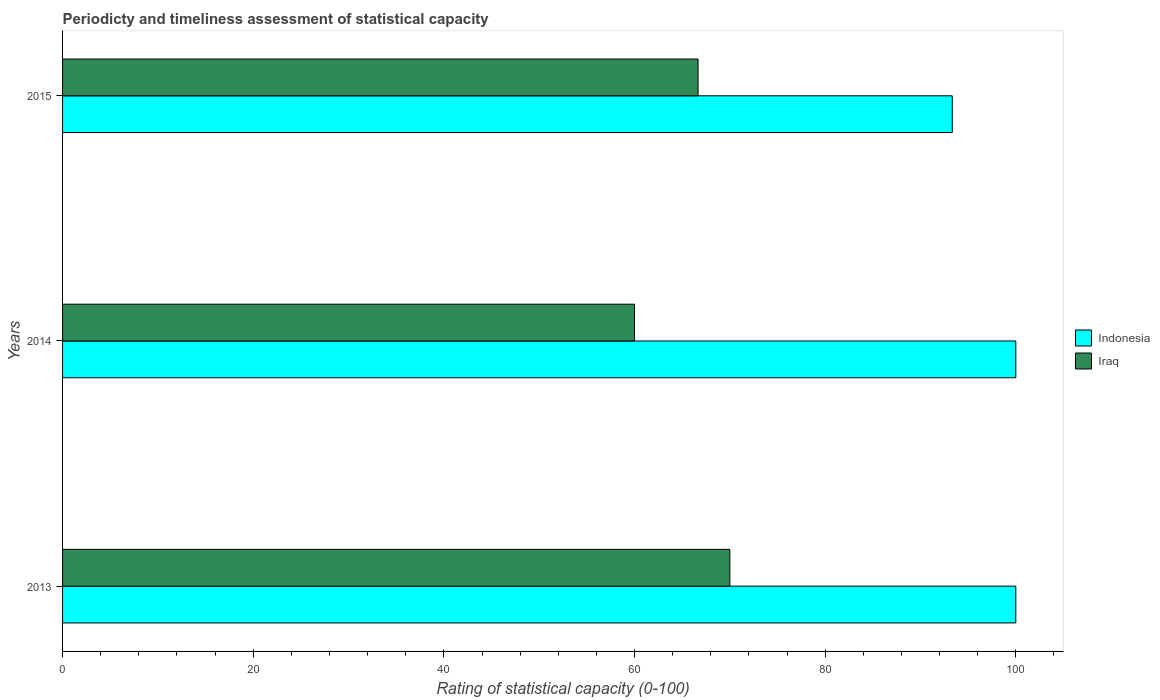How many different coloured bars are there?
Your answer should be compact. 2. How many groups of bars are there?
Your answer should be very brief. 3. What is the label of the 1st group of bars from the top?
Make the answer very short. 2015. In how many cases, is the number of bars for a given year not equal to the number of legend labels?
Provide a short and direct response. 0. What is the rating of statistical capacity in Iraq in 2015?
Keep it short and to the point. 66.67. Across all years, what is the minimum rating of statistical capacity in Indonesia?
Ensure brevity in your answer.  93.33. In which year was the rating of statistical capacity in Indonesia maximum?
Offer a terse response. 2013. In which year was the rating of statistical capacity in Indonesia minimum?
Provide a succinct answer. 2015. What is the total rating of statistical capacity in Indonesia in the graph?
Keep it short and to the point. 293.33. What is the difference between the rating of statistical capacity in Indonesia in 2013 and that in 2015?
Offer a terse response. 6.67. What is the average rating of statistical capacity in Iraq per year?
Your answer should be compact. 65.56. In how many years, is the rating of statistical capacity in Iraq greater than 32 ?
Your answer should be very brief. 3. What is the ratio of the rating of statistical capacity in Iraq in 2013 to that in 2015?
Provide a succinct answer. 1.05. Is the difference between the rating of statistical capacity in Indonesia in 2013 and 2014 greater than the difference between the rating of statistical capacity in Iraq in 2013 and 2014?
Ensure brevity in your answer.  No. What is the difference between the highest and the second highest rating of statistical capacity in Iraq?
Offer a very short reply. 3.33. What is the difference between the highest and the lowest rating of statistical capacity in Indonesia?
Ensure brevity in your answer.  6.67. What does the 2nd bar from the top in 2014 represents?
Provide a succinct answer. Indonesia. What does the 1st bar from the bottom in 2014 represents?
Provide a short and direct response. Indonesia. How many bars are there?
Make the answer very short. 6. What is the difference between two consecutive major ticks on the X-axis?
Give a very brief answer. 20. Are the values on the major ticks of X-axis written in scientific E-notation?
Provide a succinct answer. No. Does the graph contain any zero values?
Your answer should be compact. No. How are the legend labels stacked?
Your answer should be compact. Vertical. What is the title of the graph?
Offer a terse response. Periodicty and timeliness assessment of statistical capacity. Does "Kenya" appear as one of the legend labels in the graph?
Provide a succinct answer. No. What is the label or title of the X-axis?
Provide a succinct answer. Rating of statistical capacity (0-100). What is the Rating of statistical capacity (0-100) of Indonesia in 2013?
Your response must be concise. 100. What is the Rating of statistical capacity (0-100) of Iraq in 2013?
Keep it short and to the point. 70. What is the Rating of statistical capacity (0-100) in Indonesia in 2014?
Your answer should be compact. 100. What is the Rating of statistical capacity (0-100) in Indonesia in 2015?
Ensure brevity in your answer.  93.33. What is the Rating of statistical capacity (0-100) in Iraq in 2015?
Offer a terse response. 66.67. Across all years, what is the maximum Rating of statistical capacity (0-100) of Iraq?
Offer a very short reply. 70. Across all years, what is the minimum Rating of statistical capacity (0-100) of Indonesia?
Your answer should be very brief. 93.33. Across all years, what is the minimum Rating of statistical capacity (0-100) in Iraq?
Give a very brief answer. 60. What is the total Rating of statistical capacity (0-100) of Indonesia in the graph?
Make the answer very short. 293.33. What is the total Rating of statistical capacity (0-100) of Iraq in the graph?
Your response must be concise. 196.67. What is the difference between the Rating of statistical capacity (0-100) in Iraq in 2013 and that in 2014?
Your response must be concise. 10. What is the difference between the Rating of statistical capacity (0-100) in Indonesia in 2013 and that in 2015?
Ensure brevity in your answer.  6.67. What is the difference between the Rating of statistical capacity (0-100) of Indonesia in 2014 and that in 2015?
Your answer should be compact. 6.67. What is the difference between the Rating of statistical capacity (0-100) of Iraq in 2014 and that in 2015?
Your answer should be compact. -6.67. What is the difference between the Rating of statistical capacity (0-100) of Indonesia in 2013 and the Rating of statistical capacity (0-100) of Iraq in 2015?
Keep it short and to the point. 33.33. What is the difference between the Rating of statistical capacity (0-100) of Indonesia in 2014 and the Rating of statistical capacity (0-100) of Iraq in 2015?
Keep it short and to the point. 33.33. What is the average Rating of statistical capacity (0-100) in Indonesia per year?
Make the answer very short. 97.78. What is the average Rating of statistical capacity (0-100) of Iraq per year?
Offer a terse response. 65.56. In the year 2013, what is the difference between the Rating of statistical capacity (0-100) of Indonesia and Rating of statistical capacity (0-100) of Iraq?
Provide a succinct answer. 30. In the year 2014, what is the difference between the Rating of statistical capacity (0-100) in Indonesia and Rating of statistical capacity (0-100) in Iraq?
Ensure brevity in your answer.  40. In the year 2015, what is the difference between the Rating of statistical capacity (0-100) in Indonesia and Rating of statistical capacity (0-100) in Iraq?
Your answer should be compact. 26.67. What is the ratio of the Rating of statistical capacity (0-100) in Indonesia in 2013 to that in 2015?
Give a very brief answer. 1.07. What is the ratio of the Rating of statistical capacity (0-100) in Iraq in 2013 to that in 2015?
Give a very brief answer. 1.05. What is the ratio of the Rating of statistical capacity (0-100) of Indonesia in 2014 to that in 2015?
Provide a short and direct response. 1.07. What is the ratio of the Rating of statistical capacity (0-100) in Iraq in 2014 to that in 2015?
Offer a very short reply. 0.9. What is the difference between the highest and the second highest Rating of statistical capacity (0-100) of Indonesia?
Keep it short and to the point. 0. What is the difference between the highest and the second highest Rating of statistical capacity (0-100) of Iraq?
Provide a succinct answer. 3.33. What is the difference between the highest and the lowest Rating of statistical capacity (0-100) in Indonesia?
Make the answer very short. 6.67. 